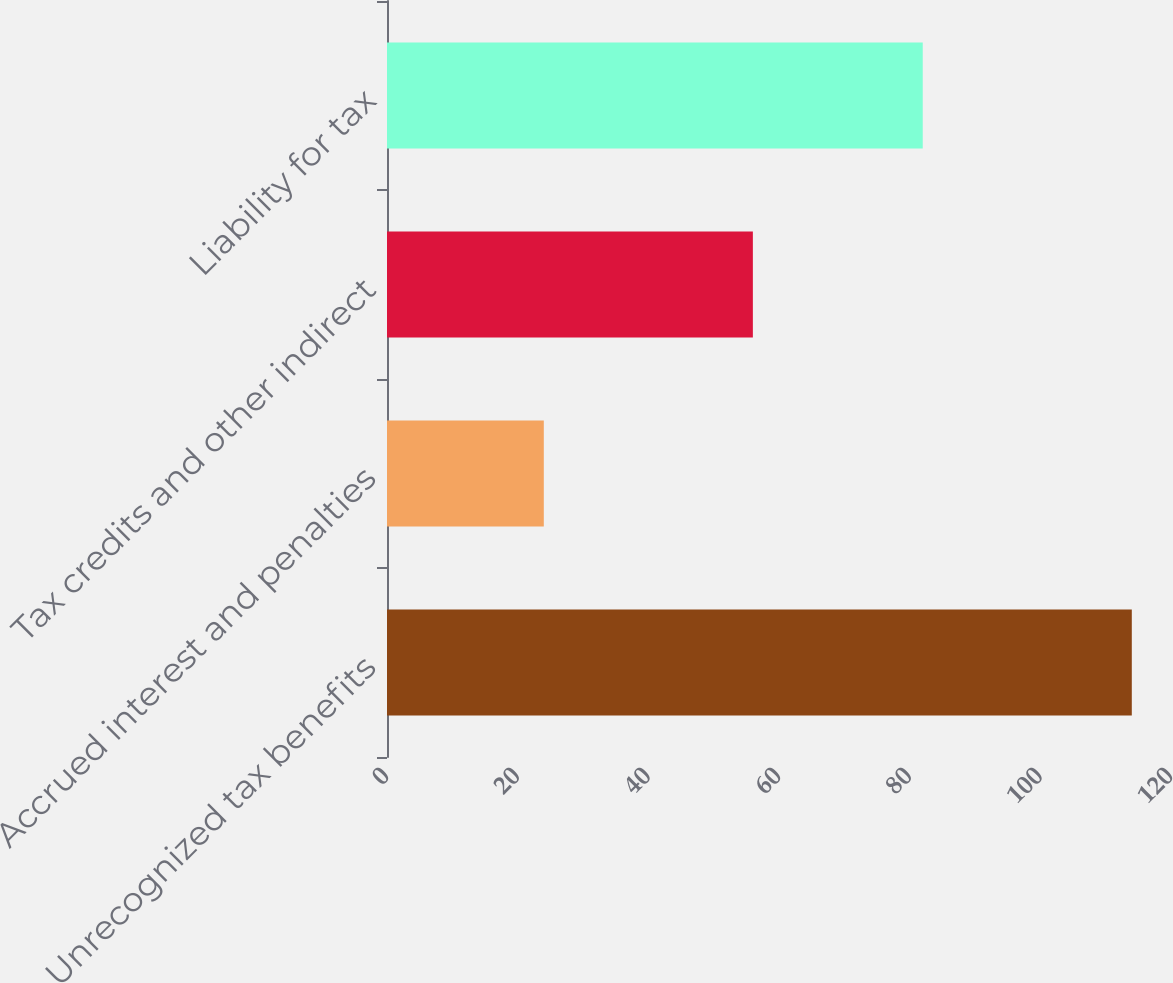Convert chart to OTSL. <chart><loc_0><loc_0><loc_500><loc_500><bar_chart><fcel>Unrecognized tax benefits<fcel>Accrued interest and penalties<fcel>Tax credits and other indirect<fcel>Liability for tax<nl><fcel>114<fcel>24<fcel>56<fcel>82<nl></chart> 